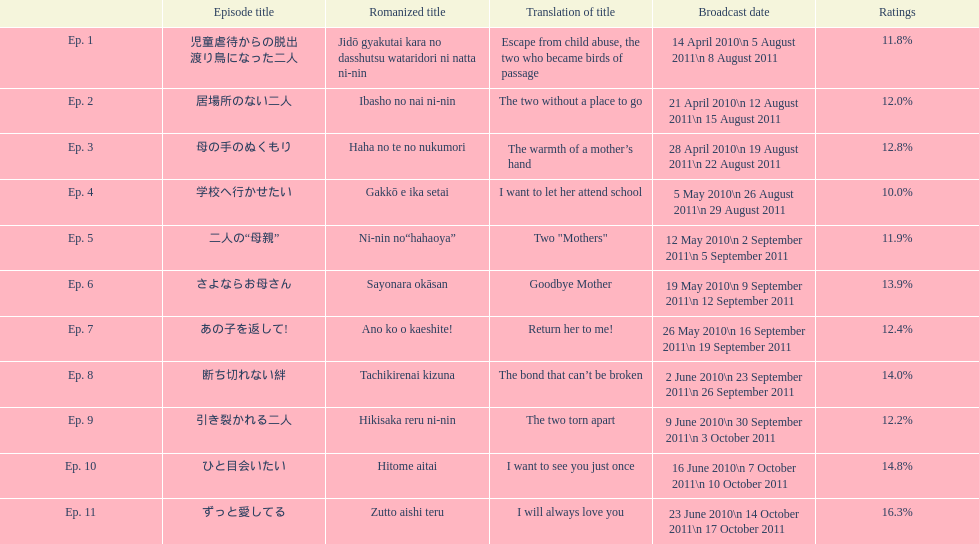Apart from the 10th episode, which other episode holds a 14% rating? Ep. 8. 